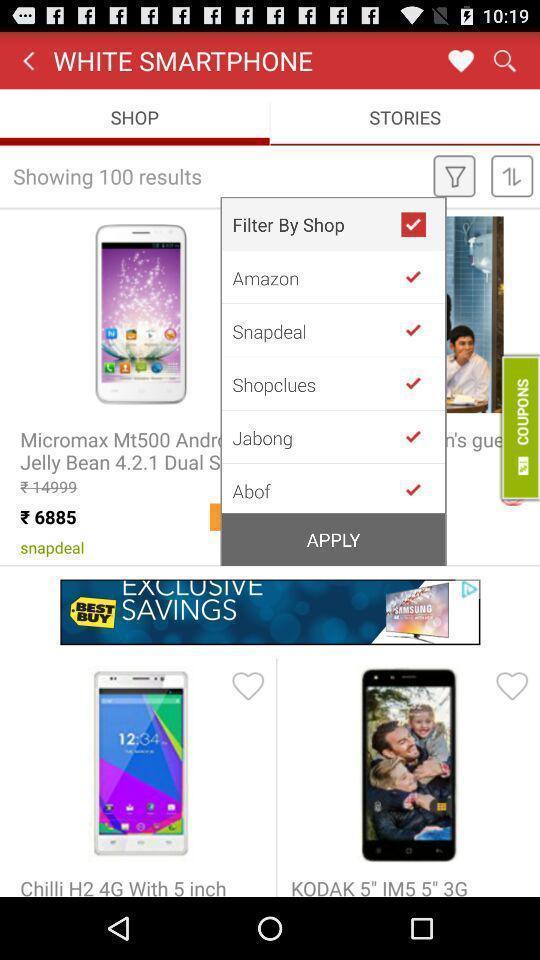Describe the key features of this screenshot. Pop-up showing to select the option in shopping app. 